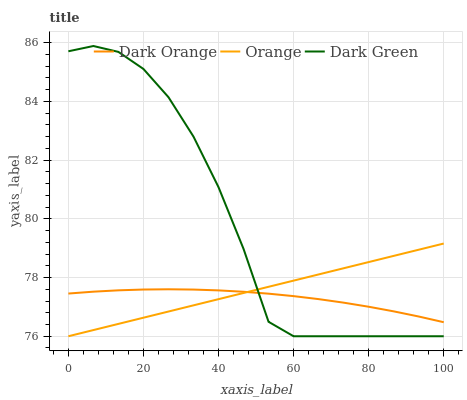Does Dark Orange have the minimum area under the curve?
Answer yes or no. Yes. Does Dark Green have the maximum area under the curve?
Answer yes or no. Yes. Does Dark Green have the minimum area under the curve?
Answer yes or no. No. Does Dark Orange have the maximum area under the curve?
Answer yes or no. No. Is Orange the smoothest?
Answer yes or no. Yes. Is Dark Green the roughest?
Answer yes or no. Yes. Is Dark Orange the smoothest?
Answer yes or no. No. Is Dark Orange the roughest?
Answer yes or no. No. Does Orange have the lowest value?
Answer yes or no. Yes. Does Dark Orange have the lowest value?
Answer yes or no. No. Does Dark Green have the highest value?
Answer yes or no. Yes. Does Dark Orange have the highest value?
Answer yes or no. No. Does Orange intersect Dark Orange?
Answer yes or no. Yes. Is Orange less than Dark Orange?
Answer yes or no. No. Is Orange greater than Dark Orange?
Answer yes or no. No. 